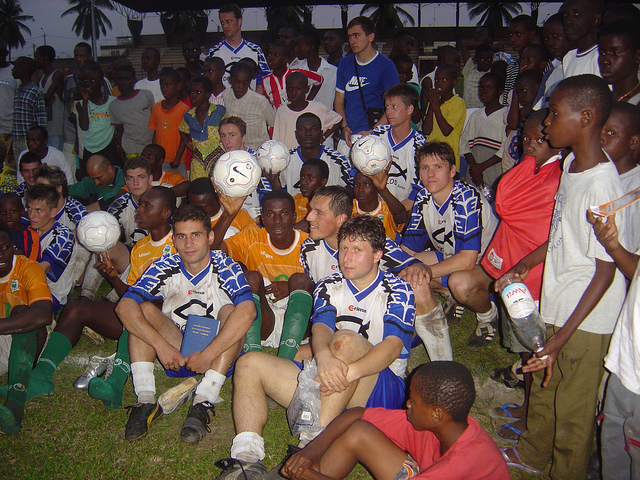Please extract the text content from this image. OS 